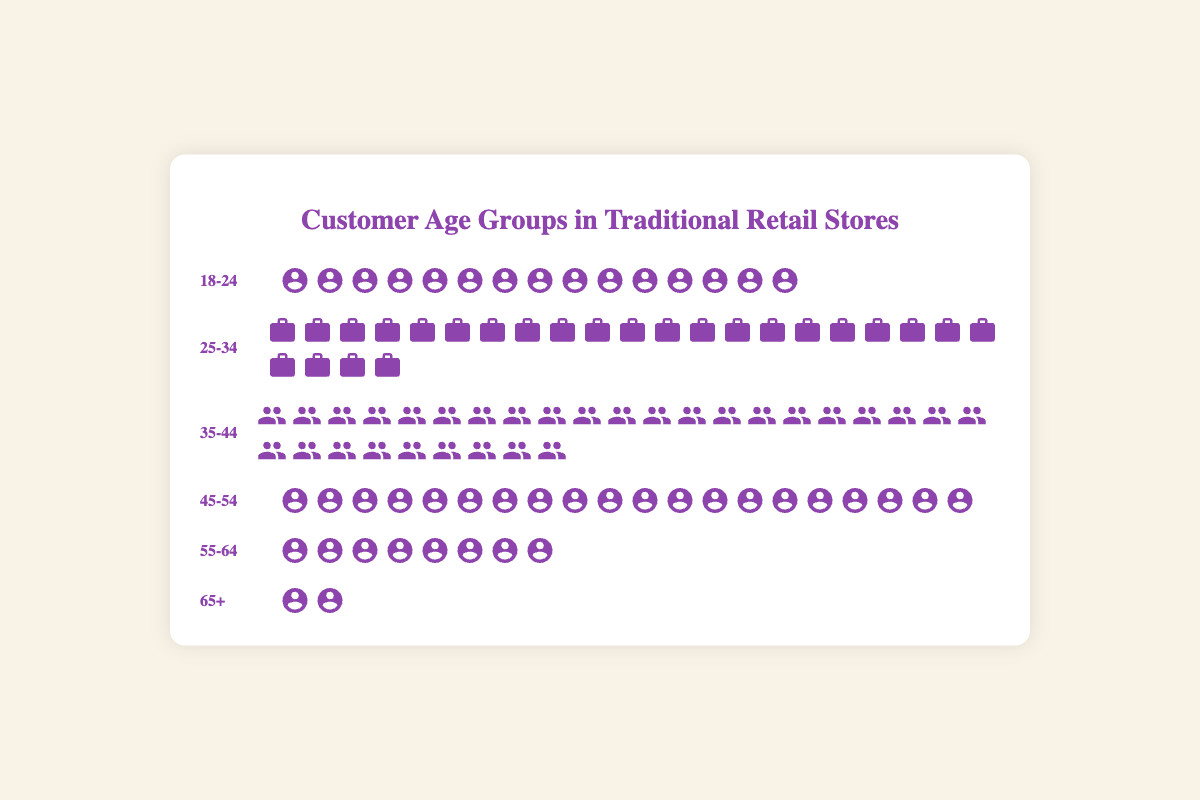What is the age group for the icons representing the elderly? The label "65+" represents the elderly age group as indicated by the icons.
Answer: 65+ Which age group has the most icons in the plot? Count the icons for each age group; the group with 30 icons is "35-44."
Answer: 35-44 What is the total number of customers represented in the plot? Sum the counts of all age groups: 15 + 25 + 30 + 20 + 8 + 2 = 100.
Answer: 100 Which age group has fewer icons, 55-64 or 65+? Compare the number of icons for "55-64" (8 icons) and "65+" (2 icons).
Answer: 65+ What percentage of the total customers are in the 35-44 age group? Divide the number of customers in the 35-44 group by the total number of customers and multiply by 100: (30 / 100) * 100 = 30%.
Answer: 30% How many more customers are there in the 25-34 age group than in the 45-54 age group? Subtract the count in the 45-54 age group (20) from the count in the 25-34 age group (25): 25 - 20 = 5.
Answer: 5 Compare the number of customers in the 18-24 age group to the number in the 55-64 age group. There are 15 customers in the 18-24 group and 8 customers in the 55-64 group, so 18-24 has more.
Answer: 18-24 has more What is the median age group based on the number of customers? The counts, in order, are: 2, 8, 15, 20, 25, and 30. The median is the average of the 3rd and 4th highest counts: (15 + 20) / 2 = 17.5. The median age group occurs at the point dividing the lower half from the upper half, which corresponds to 25-34 and 35-44.
Answer: 25-34 and 35-44 How do the numbers of young adults (18-24) compare to the middle-aged (45-54)? There are 15 icons for the 18-24 group and 20 for the 45-54 group. Therefore, the middle-aged group has more.
Answer: Middle-aged group has more 